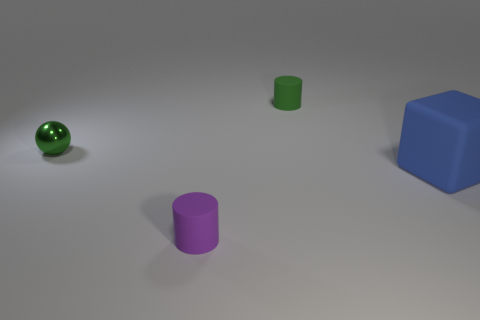Is there any other thing that is made of the same material as the tiny ball?
Your response must be concise. No. Is the material of the tiny purple object the same as the small cylinder behind the purple cylinder?
Give a very brief answer. Yes. How many objects are either cyan matte things or blue matte objects?
Keep it short and to the point. 1. Is there a big blue rubber block?
Provide a short and direct response. Yes. What shape is the small green thing in front of the small thing that is on the right side of the purple object?
Your response must be concise. Sphere. What number of things are either green rubber things that are behind the large rubber cube or small matte objects in front of the shiny sphere?
Keep it short and to the point. 2. What is the material of the green ball that is the same size as the purple thing?
Offer a very short reply. Metal. What color is the large rubber block?
Your answer should be very brief. Blue. What material is the object that is on the left side of the green rubber thing and behind the large blue matte cube?
Make the answer very short. Metal. Are there any purple objects to the right of the cylinder that is behind the small matte cylinder that is in front of the blue cube?
Provide a short and direct response. No. 